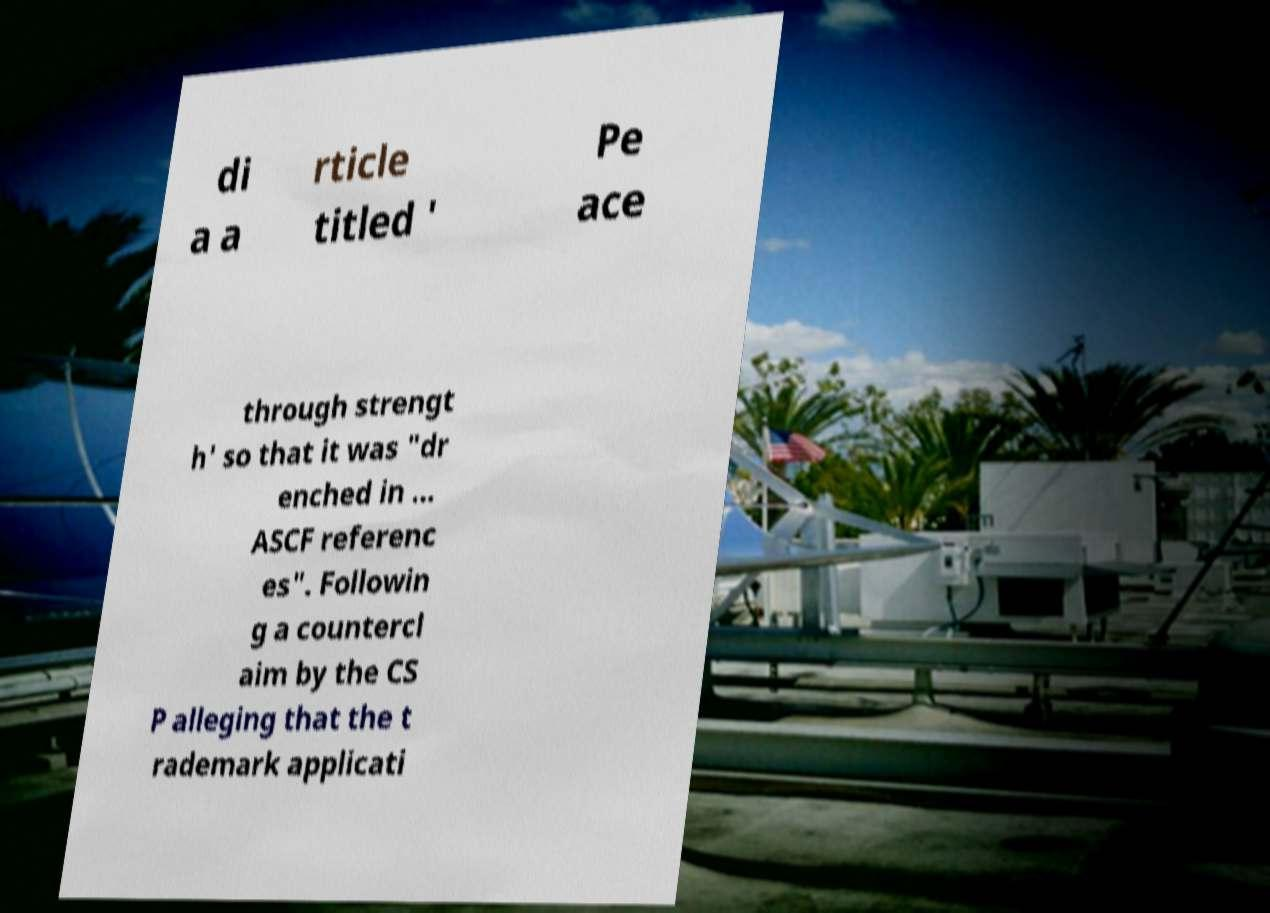Please identify and transcribe the text found in this image. di a a rticle titled ' Pe ace through strengt h' so that it was "dr enched in ... ASCF referenc es". Followin g a countercl aim by the CS P alleging that the t rademark applicati 